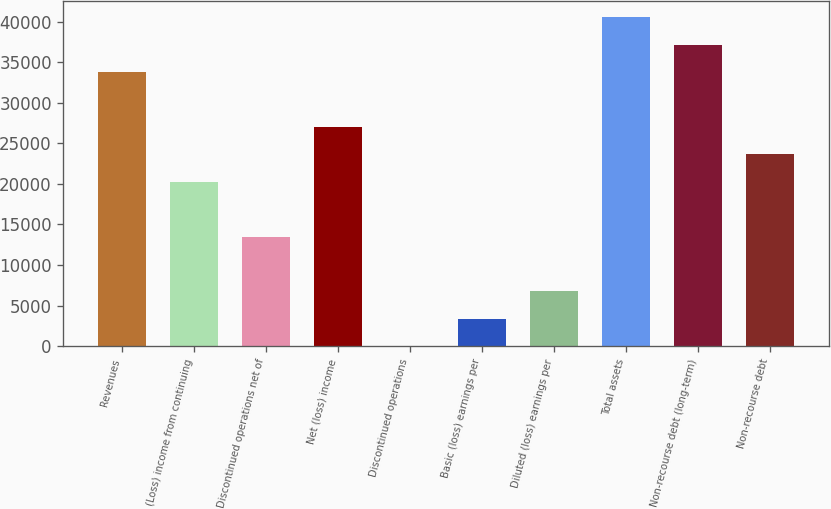<chart> <loc_0><loc_0><loc_500><loc_500><bar_chart><fcel>Revenues<fcel>(Loss) income from continuing<fcel>Discontinued operations net of<fcel>Net (loss) income<fcel>Discontinued operations<fcel>Basic (loss) earnings per<fcel>Diluted (loss) earnings per<fcel>Total assets<fcel>Non-recourse debt (long-term)<fcel>Non-recourse debt<nl><fcel>33776<fcel>20266<fcel>13511<fcel>27021<fcel>1.05<fcel>3378.55<fcel>6756.05<fcel>40531<fcel>37153.5<fcel>23643.5<nl></chart> 